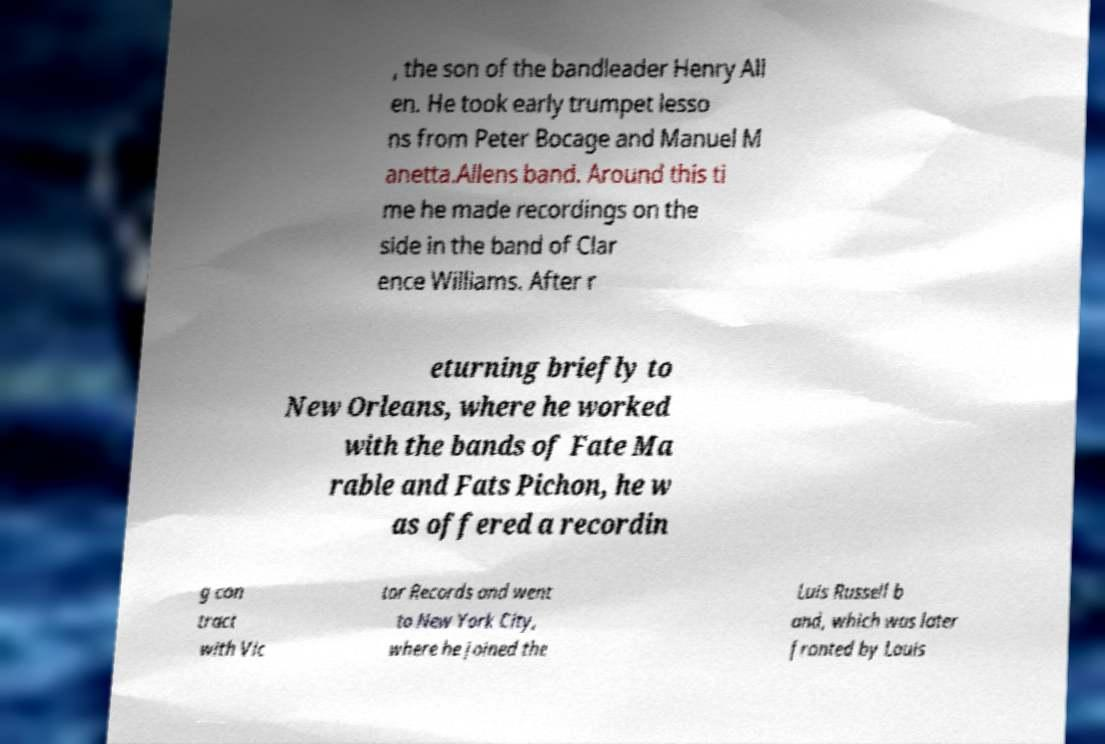Could you extract and type out the text from this image? , the son of the bandleader Henry All en. He took early trumpet lesso ns from Peter Bocage and Manuel M anetta.Allens band. Around this ti me he made recordings on the side in the band of Clar ence Williams. After r eturning briefly to New Orleans, where he worked with the bands of Fate Ma rable and Fats Pichon, he w as offered a recordin g con tract with Vic tor Records and went to New York City, where he joined the Luis Russell b and, which was later fronted by Louis 